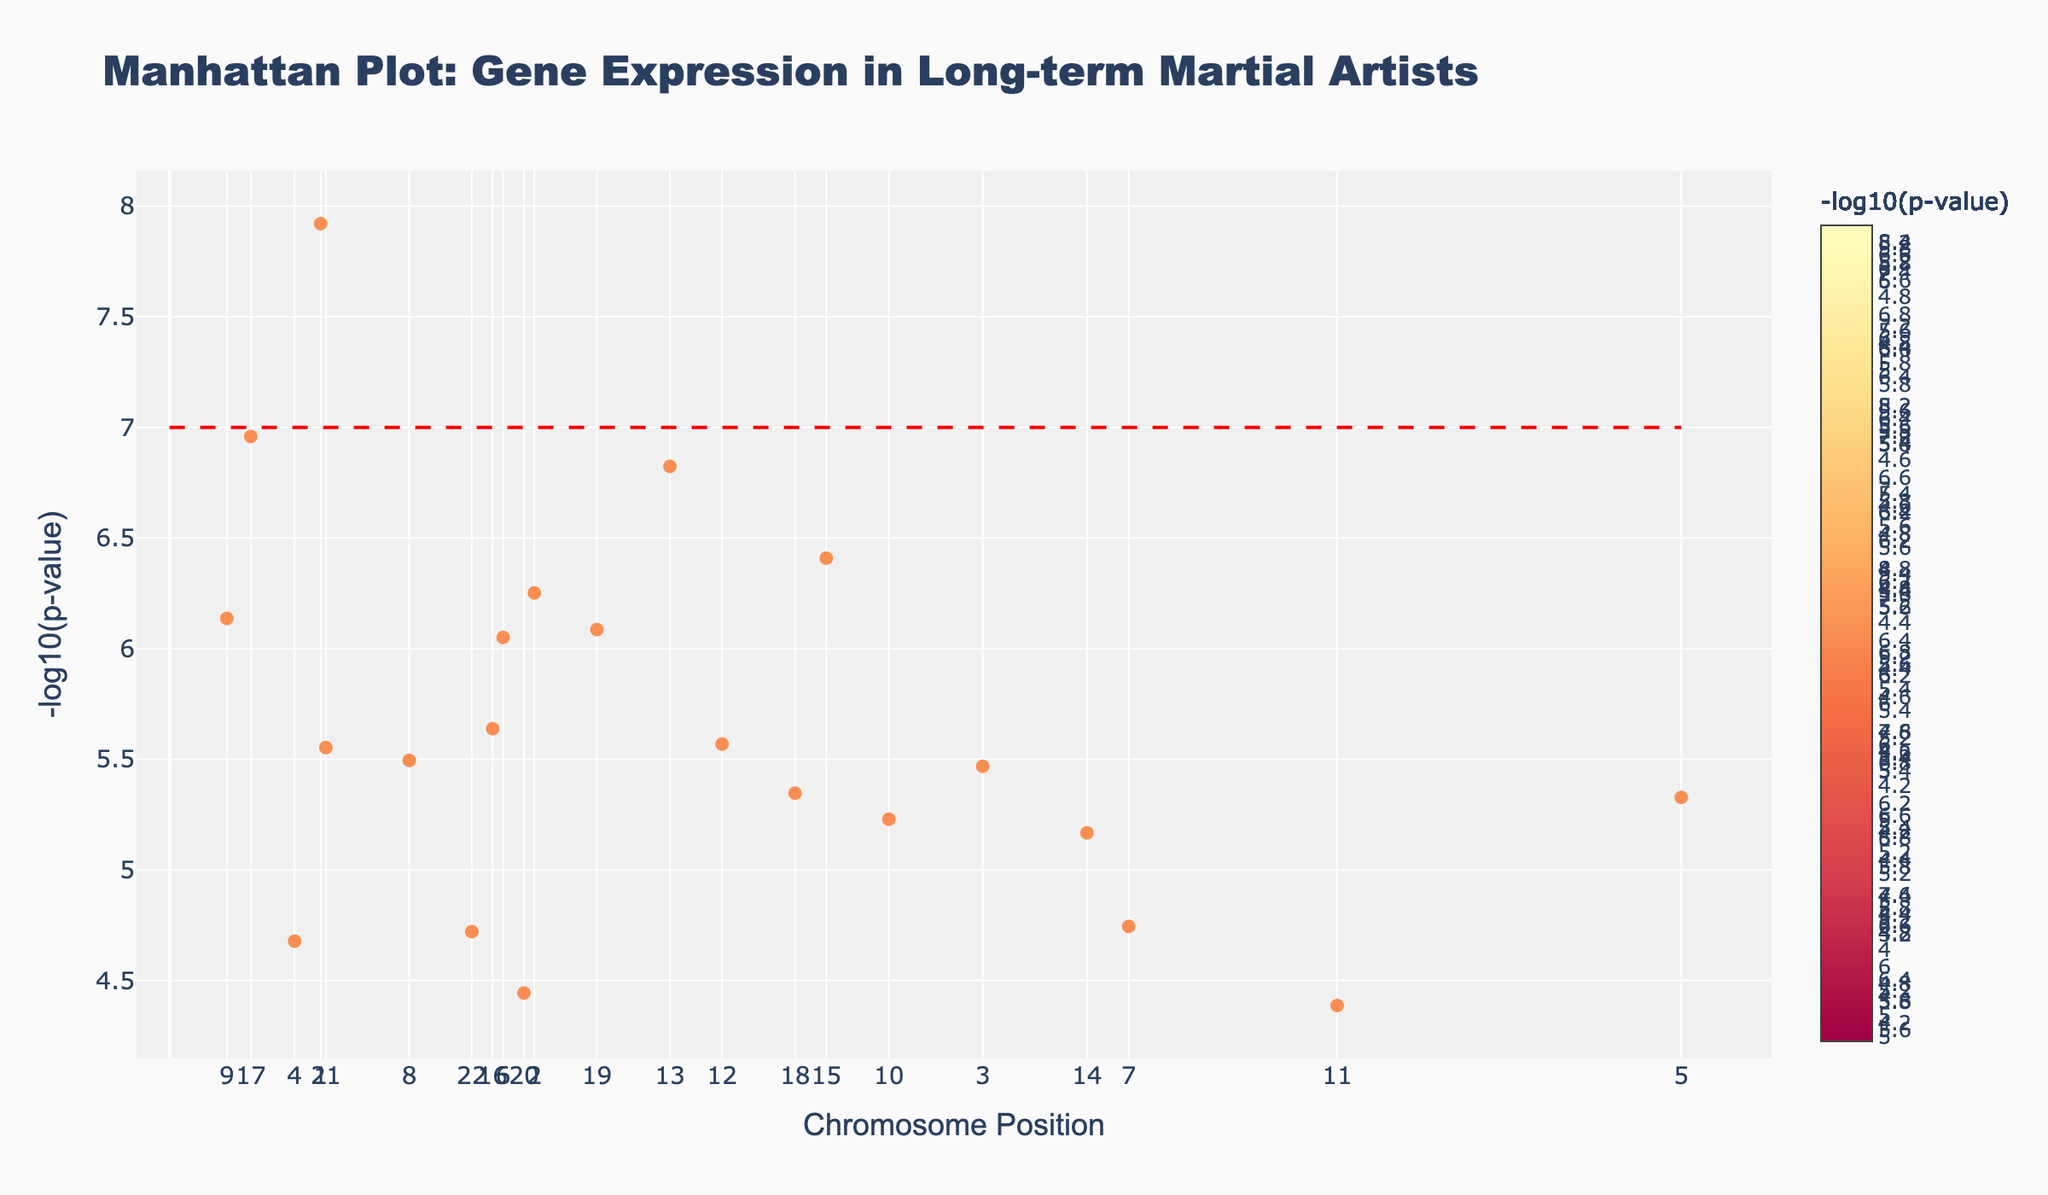What is the title of the plot? The title is located at the top of the plot and provides a brief description of what the plot represents.
Answer: Manhattan Plot: Gene Expression in Long-term Martial Artists What does the y-axis represent? The y-axis is labeled with its title, which describes what the numerical values indicate.
Answer: -log10(p-value) Which gene has the smallest p-value? To find the smallest p-value, look for the highest point on the y-axis because the y-axis represents -log10(p-value), and a higher value corresponds to a smaller p-value.
Answer: FOXO3 How many unique chromosomes are represented in the plot? Count the number of distinct labels on the x-axis representing different chromosomes.
Answer: 22 Which chromosome has the gene with the highest -log10(p-value)? Identify the tallest point (highest -log10(p-value)) and check its chromosome label on the x-axis.
Answer: Chromosome 1 What is the significance threshold indicated by the red dashed line? Look at the value on the y-axis where the horizontal red dashed line is drawn.
Answer: 7 Which gene related to muscle strength is shown on the plot and what chromosome is it located on? Find the gene labeled with the trait related to muscle strength and check its chromosome label on the x-axis for its location.
Answer: ACTN3 on Chromosome 9 Compare the positions of FOXO3 and FKBP5 on their respective chromosomes. Which has a higher position? Check the position values for both FOXO3 and FKBP5 to compare them directly.
Answer: FOXO3 (14500000) has a higher position compared to FKBP5 (48000000) How many genes are related to stress response and where are they located? Identify the genes associated with stress response and note the positions and chromosomes they are located on.
Answer: 3 genes: FOXO3 (Chromosome 1, Position 14500000), FKBP5 (Chromosome 13, Position 48000000), CRHR1 (Chromosome 16, Position 31000000) Is there a gene associated with stress hormone regulation, and what is its -log10(p-value)? Look for the gene associated with stress hormone regulation, then refer to its vertical axis value (-log10(p-value)).
Answer: CRHR1 with -log10(p-value) around 5.64 